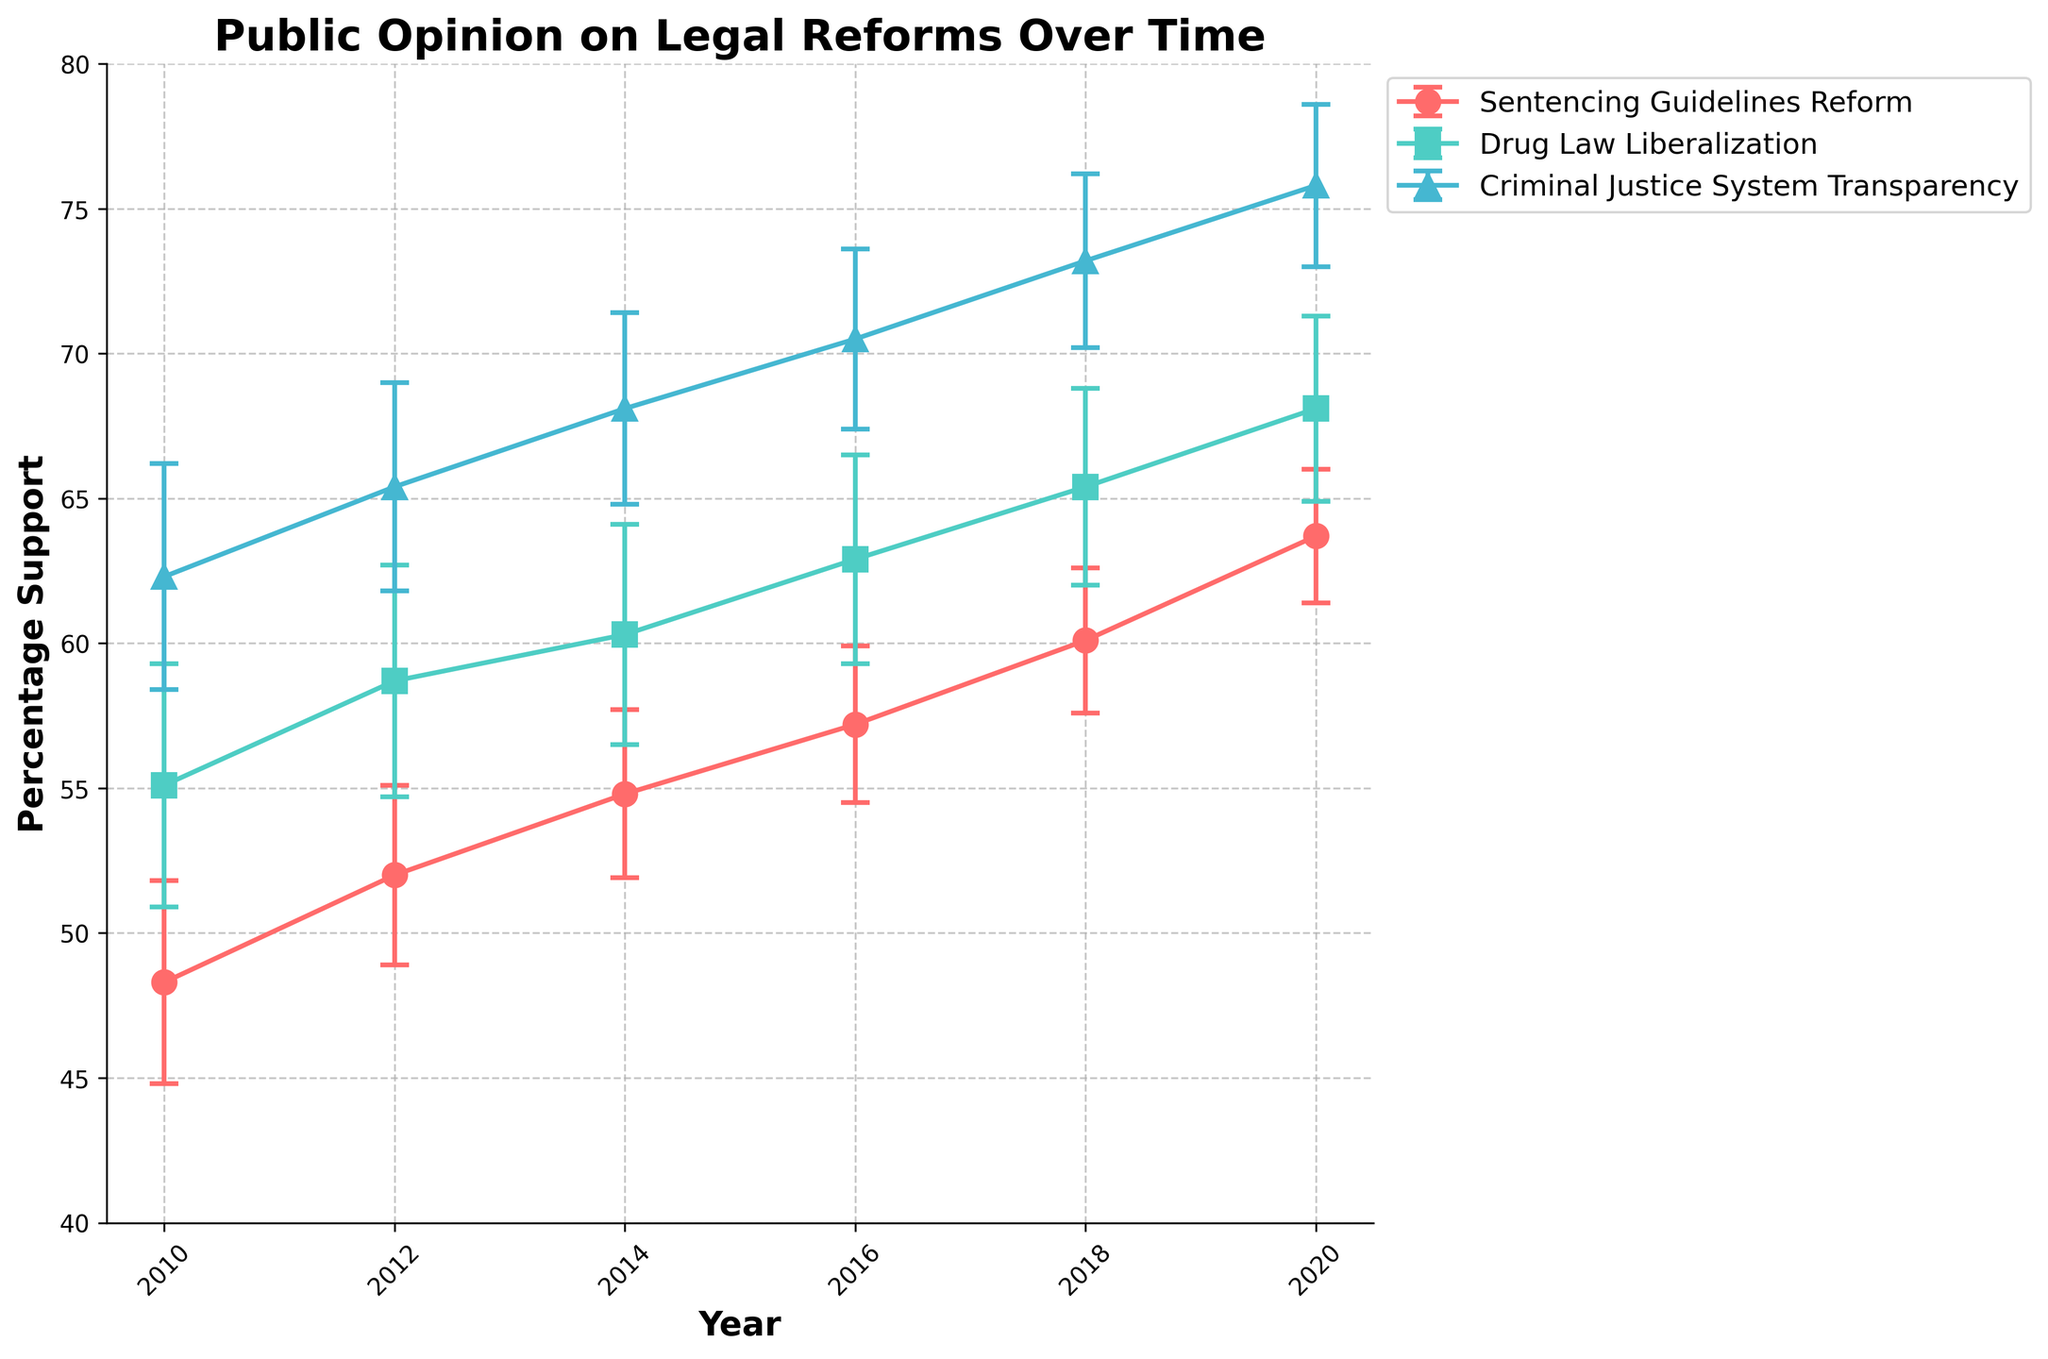What is the title of the plot? The title of the plot is located at the top center of the figure. It is in a bold font and stands out.
Answer: Public Opinion on Legal Reforms Over Time What are the years represented on the x-axis? The years on the x-axis are visible as ticks and labels, starting from the left and going to the right. They are marked and evenly spaced.
Answer: 2010, 2012, 2014, 2016, 2018, 2020 Which legal reform had the highest percentage of support in 2020? Look at the data points for 2020 on the plot. The reform with the highest point in 2020 will indicate the highest percentage support.
Answer: Criminal Justice System Transparency What is the range of percentage support shown on the y-axis? The y-axis starts from the bottom and extends to the top of the plot. The range can be observed from the minimum to the maximum value marked.
Answer: 40 to 80 How does the percentage support for Sentencing Guidelines Reform change from 2010 to 2020? Look at the data points for Sentencing Guidelines Reform starting at 2010 and ending at 2020. Observe the progression trend.
Answer: It increases from 48.3% in 2010 to 63.7% in 2020 Which reform consistently had the highest support across all years? Compare the data points of all reforms across the years. The reform consistently having the highest points will be the answer.
Answer: Criminal Justice System Transparency Which year witnessed the greatest increase in support for Drug Law Liberalization compared to the previous year? Calculate the differences in percentage support for Drug Law Liberalization between consecutive years and identify the year with the maximum increase.
Answer: 2018 In 2010, what is the range of percentage support inclusive of the standard error for Drug Law Liberalization? Add and subtract the standard error to/from the percentage support for Drug Law Liberalization in 2010 to find the range.
Answer: 50.9 to 59.3 What's the difference in percentage support for Criminal Justice System Transparency between 2012 and 2018? Subtract the percentage support for Criminal Justice System Transparency in 2012 from that in 2018.
Answer: 7.8% Which reform shows the smallest standard error in 2020? Compare the standard errors of all the reforms in 2020. The reform with the smallest value will be the one.
Answer: Sentencing Guidelines Reform 